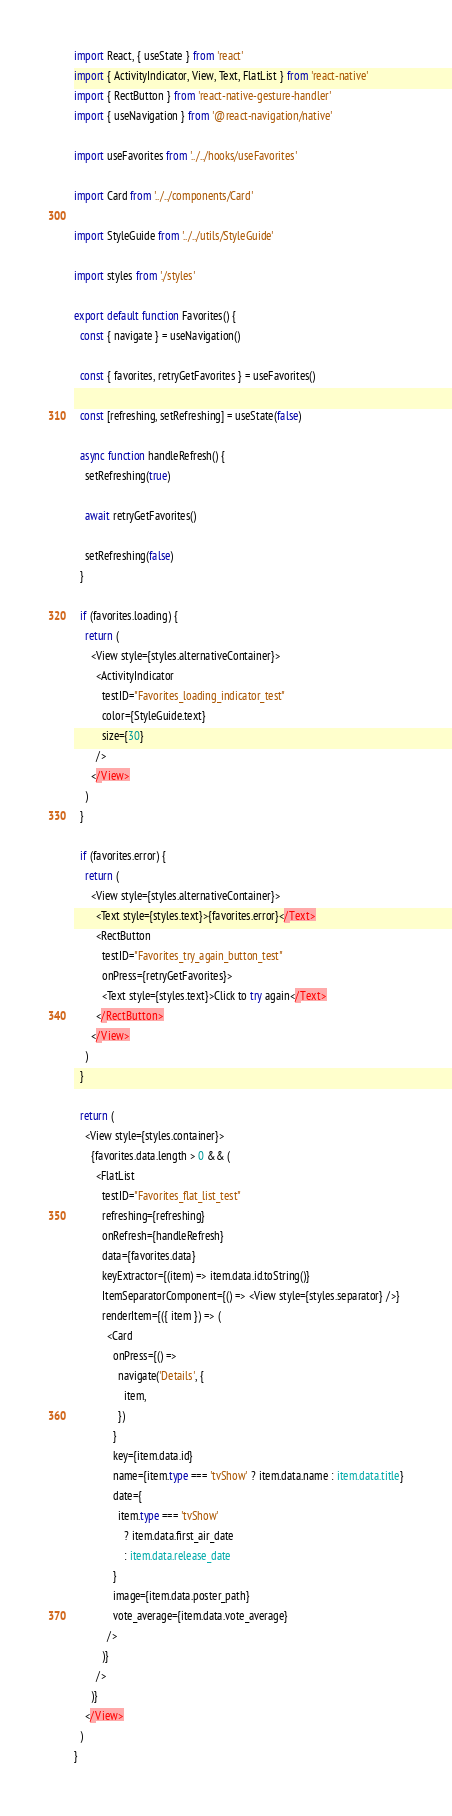<code> <loc_0><loc_0><loc_500><loc_500><_TypeScript_>import React, { useState } from 'react'
import { ActivityIndicator, View, Text, FlatList } from 'react-native'
import { RectButton } from 'react-native-gesture-handler'
import { useNavigation } from '@react-navigation/native'

import useFavorites from '../../hooks/useFavorites'

import Card from '../../components/Card'

import StyleGuide from '../../utils/StyleGuide'

import styles from './styles'

export default function Favorites() {
  const { navigate } = useNavigation()

  const { favorites, retryGetFavorites } = useFavorites()

  const [refreshing, setRefreshing] = useState(false)

  async function handleRefresh() {
    setRefreshing(true)

    await retryGetFavorites()

    setRefreshing(false)
  }

  if (favorites.loading) {
    return (
      <View style={styles.alternativeContainer}>
        <ActivityIndicator
          testID="Favorites_loading_indicator_test"
          color={StyleGuide.text}
          size={30}
        />
      </View>
    )
  }

  if (favorites.error) {
    return (
      <View style={styles.alternativeContainer}>
        <Text style={styles.text}>{favorites.error}</Text>
        <RectButton
          testID="Favorites_try_again_button_test"
          onPress={retryGetFavorites}>
          <Text style={styles.text}>Click to try again</Text>
        </RectButton>
      </View>
    )
  }

  return (
    <View style={styles.container}>
      {favorites.data.length > 0 && (
        <FlatList
          testID="Favorites_flat_list_test"
          refreshing={refreshing}
          onRefresh={handleRefresh}
          data={favorites.data}
          keyExtractor={(item) => item.data.id.toString()}
          ItemSeparatorComponent={() => <View style={styles.separator} />}
          renderItem={({ item }) => (
            <Card
              onPress={() =>
                navigate('Details', {
                  item,
                })
              }
              key={item.data.id}
              name={item.type === 'tvShow' ? item.data.name : item.data.title}
              date={
                item.type === 'tvShow'
                  ? item.data.first_air_date
                  : item.data.release_date
              }
              image={item.data.poster_path}
              vote_average={item.data.vote_average}
            />
          )}
        />
      )}
    </View>
  )
}
</code> 